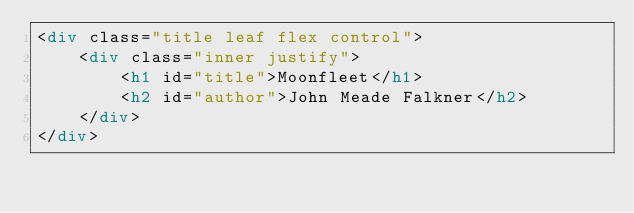<code> <loc_0><loc_0><loc_500><loc_500><_HTML_><div class="title leaf flex control">
    <div class="inner justify">
        <h1 id="title">Moonfleet</h1>
        <h2 id="author">John Meade Falkner</h2>
    </div>
</div>
</code> 